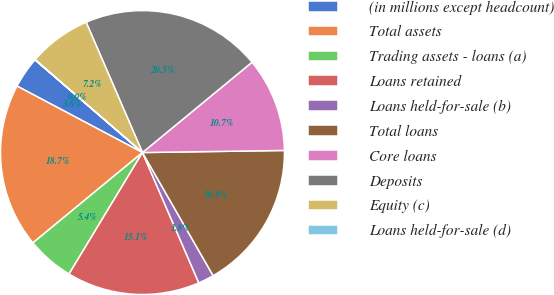<chart> <loc_0><loc_0><loc_500><loc_500><pie_chart><fcel>(in millions except headcount)<fcel>Total assets<fcel>Trading assets - loans (a)<fcel>Loans retained<fcel>Loans held-for-sale (b)<fcel>Total loans<fcel>Core loans<fcel>Deposits<fcel>Equity (c)<fcel>Loans held-for-sale (d)<nl><fcel>3.58%<fcel>18.73%<fcel>5.37%<fcel>15.15%<fcel>1.8%<fcel>16.94%<fcel>10.74%<fcel>20.52%<fcel>7.16%<fcel>0.01%<nl></chart> 